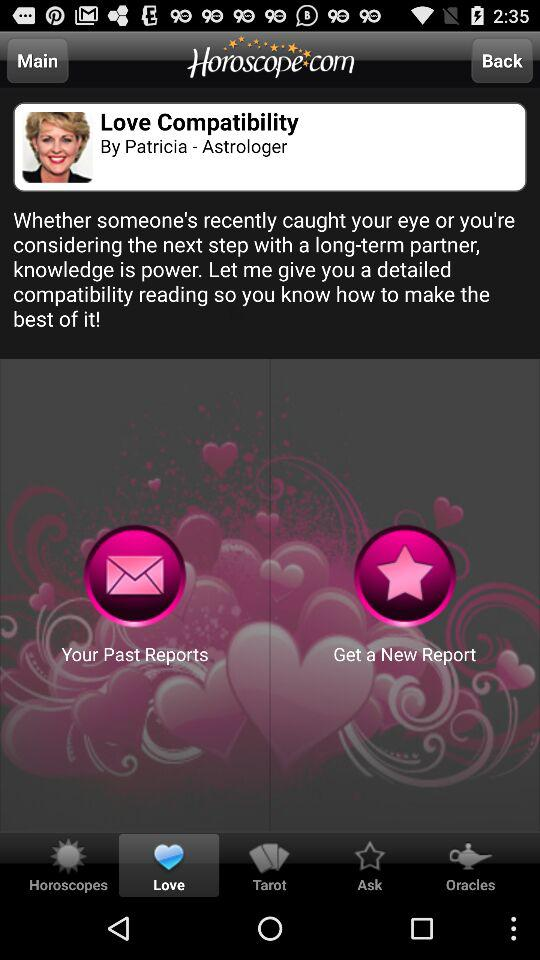What is the name of the astrologer? The name of the astrologer is Patricia. 